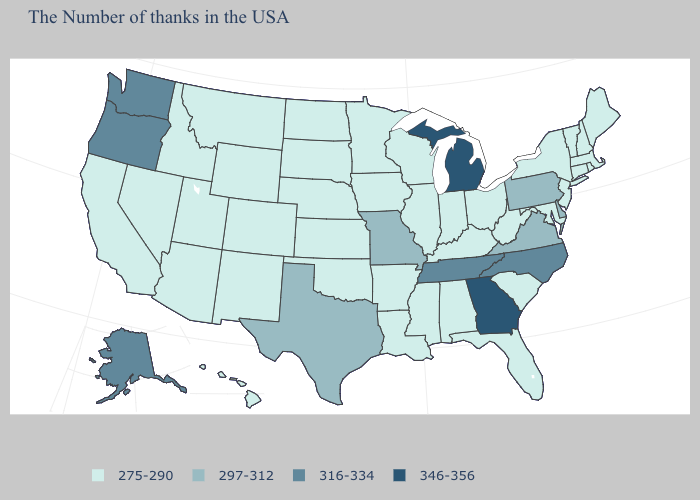Does Georgia have the highest value in the South?
Give a very brief answer. Yes. Name the states that have a value in the range 297-312?
Be succinct. Delaware, Pennsylvania, Virginia, Missouri, Texas. Is the legend a continuous bar?
Keep it brief. No. What is the value of New York?
Concise answer only. 275-290. Which states have the lowest value in the South?
Short answer required. Maryland, South Carolina, West Virginia, Florida, Kentucky, Alabama, Mississippi, Louisiana, Arkansas, Oklahoma. What is the value of Hawaii?
Give a very brief answer. 275-290. Name the states that have a value in the range 275-290?
Give a very brief answer. Maine, Massachusetts, Rhode Island, New Hampshire, Vermont, Connecticut, New York, New Jersey, Maryland, South Carolina, West Virginia, Ohio, Florida, Kentucky, Indiana, Alabama, Wisconsin, Illinois, Mississippi, Louisiana, Arkansas, Minnesota, Iowa, Kansas, Nebraska, Oklahoma, South Dakota, North Dakota, Wyoming, Colorado, New Mexico, Utah, Montana, Arizona, Idaho, Nevada, California, Hawaii. Name the states that have a value in the range 346-356?
Concise answer only. Georgia, Michigan. What is the value of Iowa?
Concise answer only. 275-290. Does Illinois have the highest value in the MidWest?
Short answer required. No. Is the legend a continuous bar?
Answer briefly. No. Does the map have missing data?
Quick response, please. No. Name the states that have a value in the range 275-290?
Give a very brief answer. Maine, Massachusetts, Rhode Island, New Hampshire, Vermont, Connecticut, New York, New Jersey, Maryland, South Carolina, West Virginia, Ohio, Florida, Kentucky, Indiana, Alabama, Wisconsin, Illinois, Mississippi, Louisiana, Arkansas, Minnesota, Iowa, Kansas, Nebraska, Oklahoma, South Dakota, North Dakota, Wyoming, Colorado, New Mexico, Utah, Montana, Arizona, Idaho, Nevada, California, Hawaii. What is the value of Washington?
Be succinct. 316-334. Does Pennsylvania have the highest value in the Northeast?
Short answer required. Yes. 